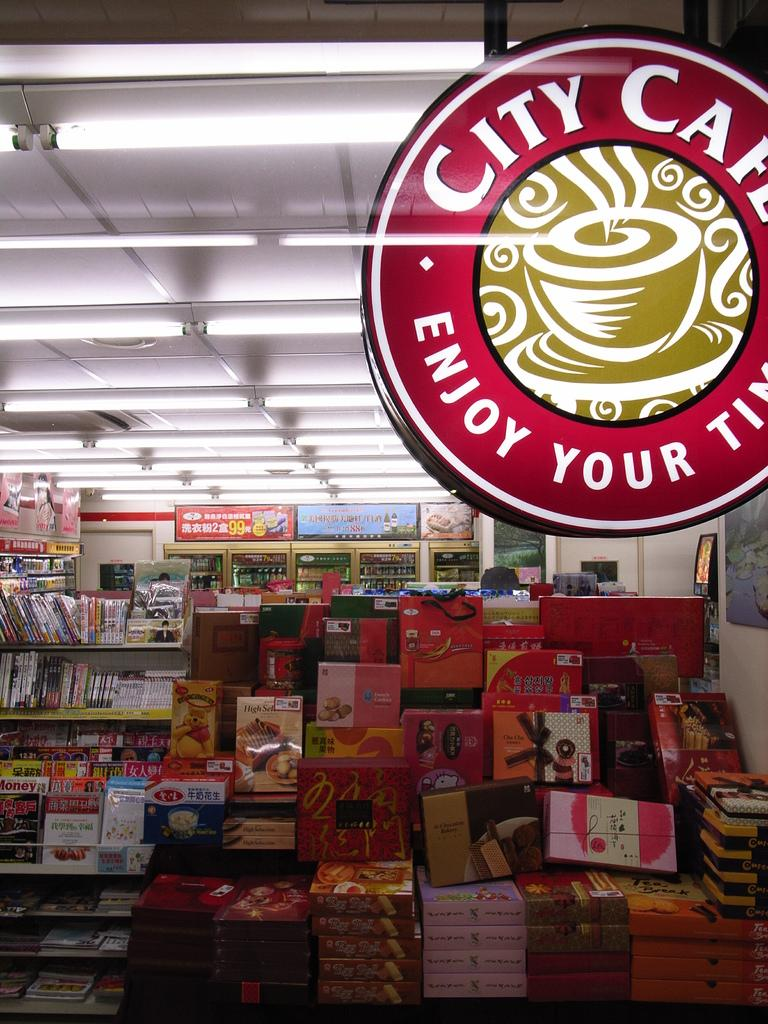<image>
Offer a succinct explanation of the picture presented. A display glass with City Cafe written in white. 